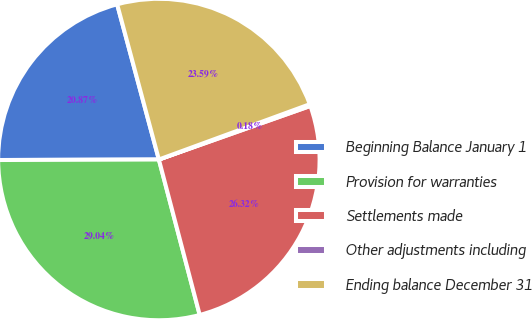<chart> <loc_0><loc_0><loc_500><loc_500><pie_chart><fcel>Beginning Balance January 1<fcel>Provision for warranties<fcel>Settlements made<fcel>Other adjustments including<fcel>Ending balance December 31<nl><fcel>20.87%<fcel>29.04%<fcel>26.32%<fcel>0.18%<fcel>23.59%<nl></chart> 